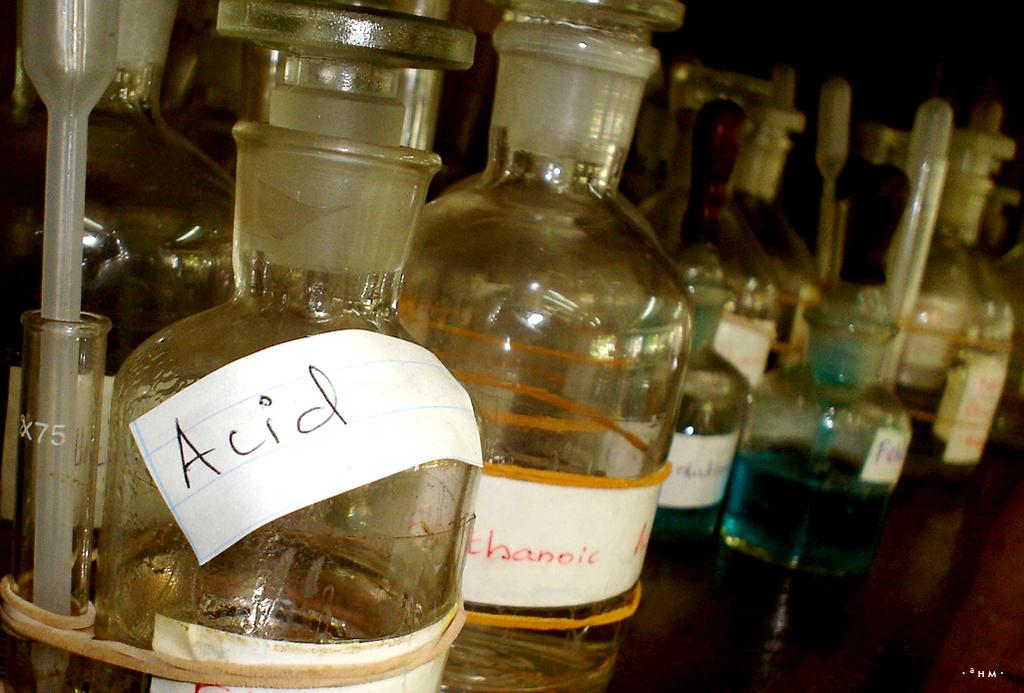<image>
Relay a brief, clear account of the picture shown. scientific bottles for things like Acid along with pipettes 